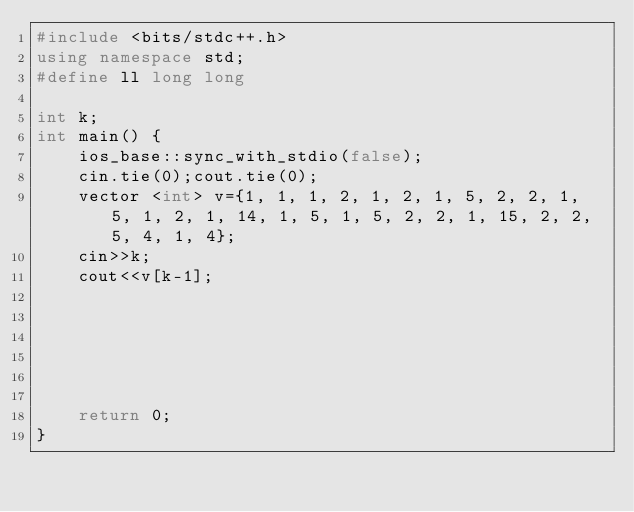<code> <loc_0><loc_0><loc_500><loc_500><_C++_>#include <bits/stdc++.h>
using namespace std;
#define ll long long 

int k;
int main() {
    ios_base::sync_with_stdio(false);
    cin.tie(0);cout.tie(0);
    vector <int> v={1, 1, 1, 2, 1, 2, 1, 5, 2, 2, 1, 5, 1, 2, 1, 14, 1, 5, 1, 5, 2, 2, 1, 15, 2, 2, 5, 4, 1, 4};
    cin>>k;
    cout<<v[k-1];
    
    




    return 0;
}</code> 